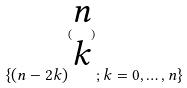<formula> <loc_0><loc_0><loc_500><loc_500>\{ ( n - 2 k ) ^ { ( \begin{matrix} n \\ k \end{matrix} ) } ; k = 0 , \dots , n \}</formula> 